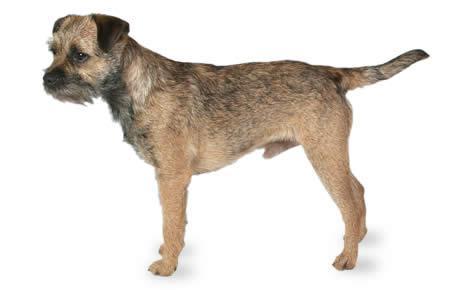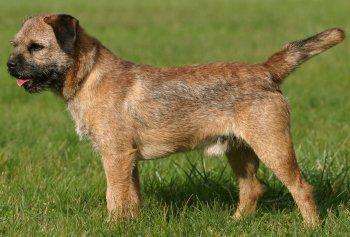The first image is the image on the left, the second image is the image on the right. Given the left and right images, does the statement "Right image shows a dog standing in profile on grass." hold true? Answer yes or no. Yes. 